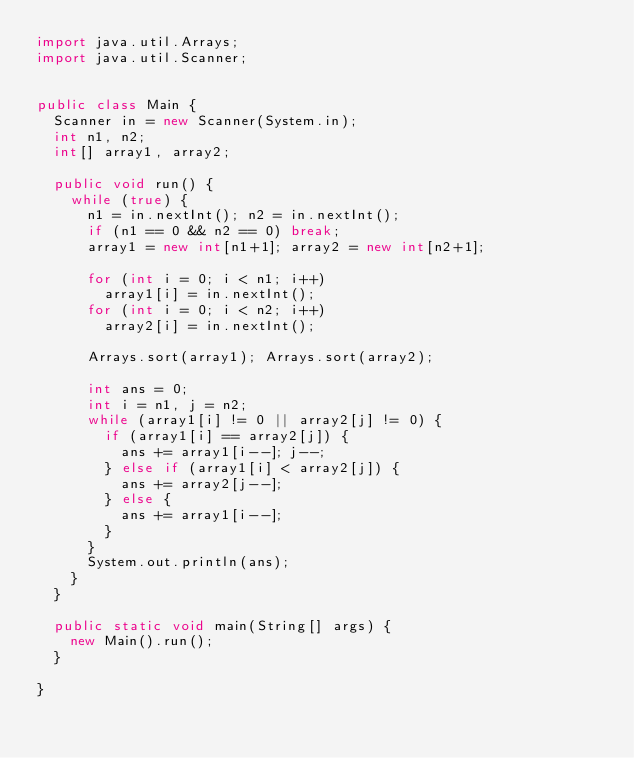<code> <loc_0><loc_0><loc_500><loc_500><_Java_>import java.util.Arrays;
import java.util.Scanner;


public class Main {
	Scanner in = new Scanner(System.in);
	int n1, n2;
	int[] array1, array2;
	
	public void run() {
		while (true) {
			n1 = in.nextInt(); n2 = in.nextInt();
			if (n1 == 0 && n2 == 0) break;
			array1 = new int[n1+1]; array2 = new int[n2+1];
			
			for (int i = 0; i < n1; i++)
				array1[i] = in.nextInt();
			for (int i = 0; i < n2; i++)
				array2[i] = in.nextInt();
			
			Arrays.sort(array1); Arrays.sort(array2);
			
			int ans = 0;
			int i = n1, j = n2;
			while (array1[i] != 0 || array2[j] != 0) {
				if (array1[i] == array2[j]) {
					ans += array1[i--]; j--;
				} else if (array1[i] < array2[j]) {
					ans += array2[j--];
				} else {
					ans += array1[i--];
				}
			}
			System.out.println(ans);
		}
	}
	
	public static void main(String[] args) {
		new Main().run();
	}

}</code> 